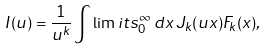<formula> <loc_0><loc_0><loc_500><loc_500>I ( u ) = \frac { 1 } { u ^ { k } } \int \lim i t s _ { 0 } ^ { \infty } \, d x \, J _ { k } ( u x ) F _ { k } ( x ) ,</formula> 